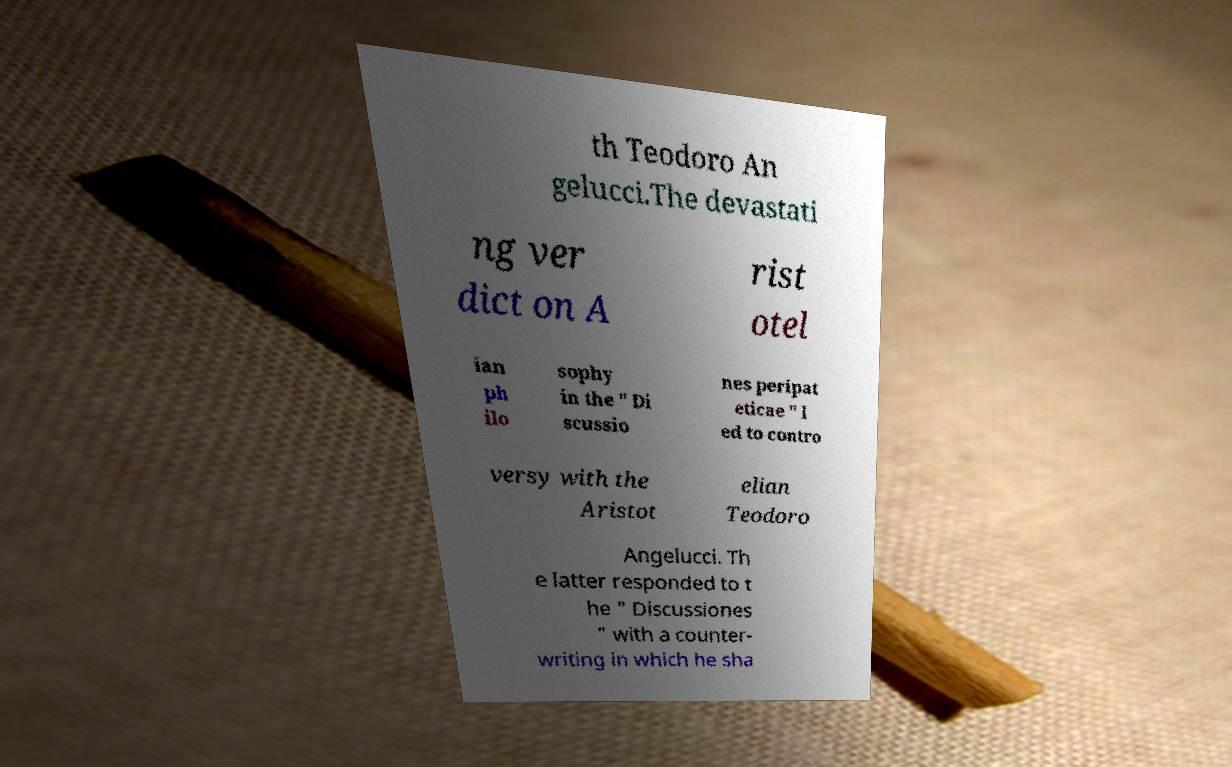There's text embedded in this image that I need extracted. Can you transcribe it verbatim? th Teodoro An gelucci.The devastati ng ver dict on A rist otel ian ph ilo sophy in the " Di scussio nes peripat eticae " l ed to contro versy with the Aristot elian Teodoro Angelucci. Th e latter responded to t he " Discussiones " with a counter- writing in which he sha 